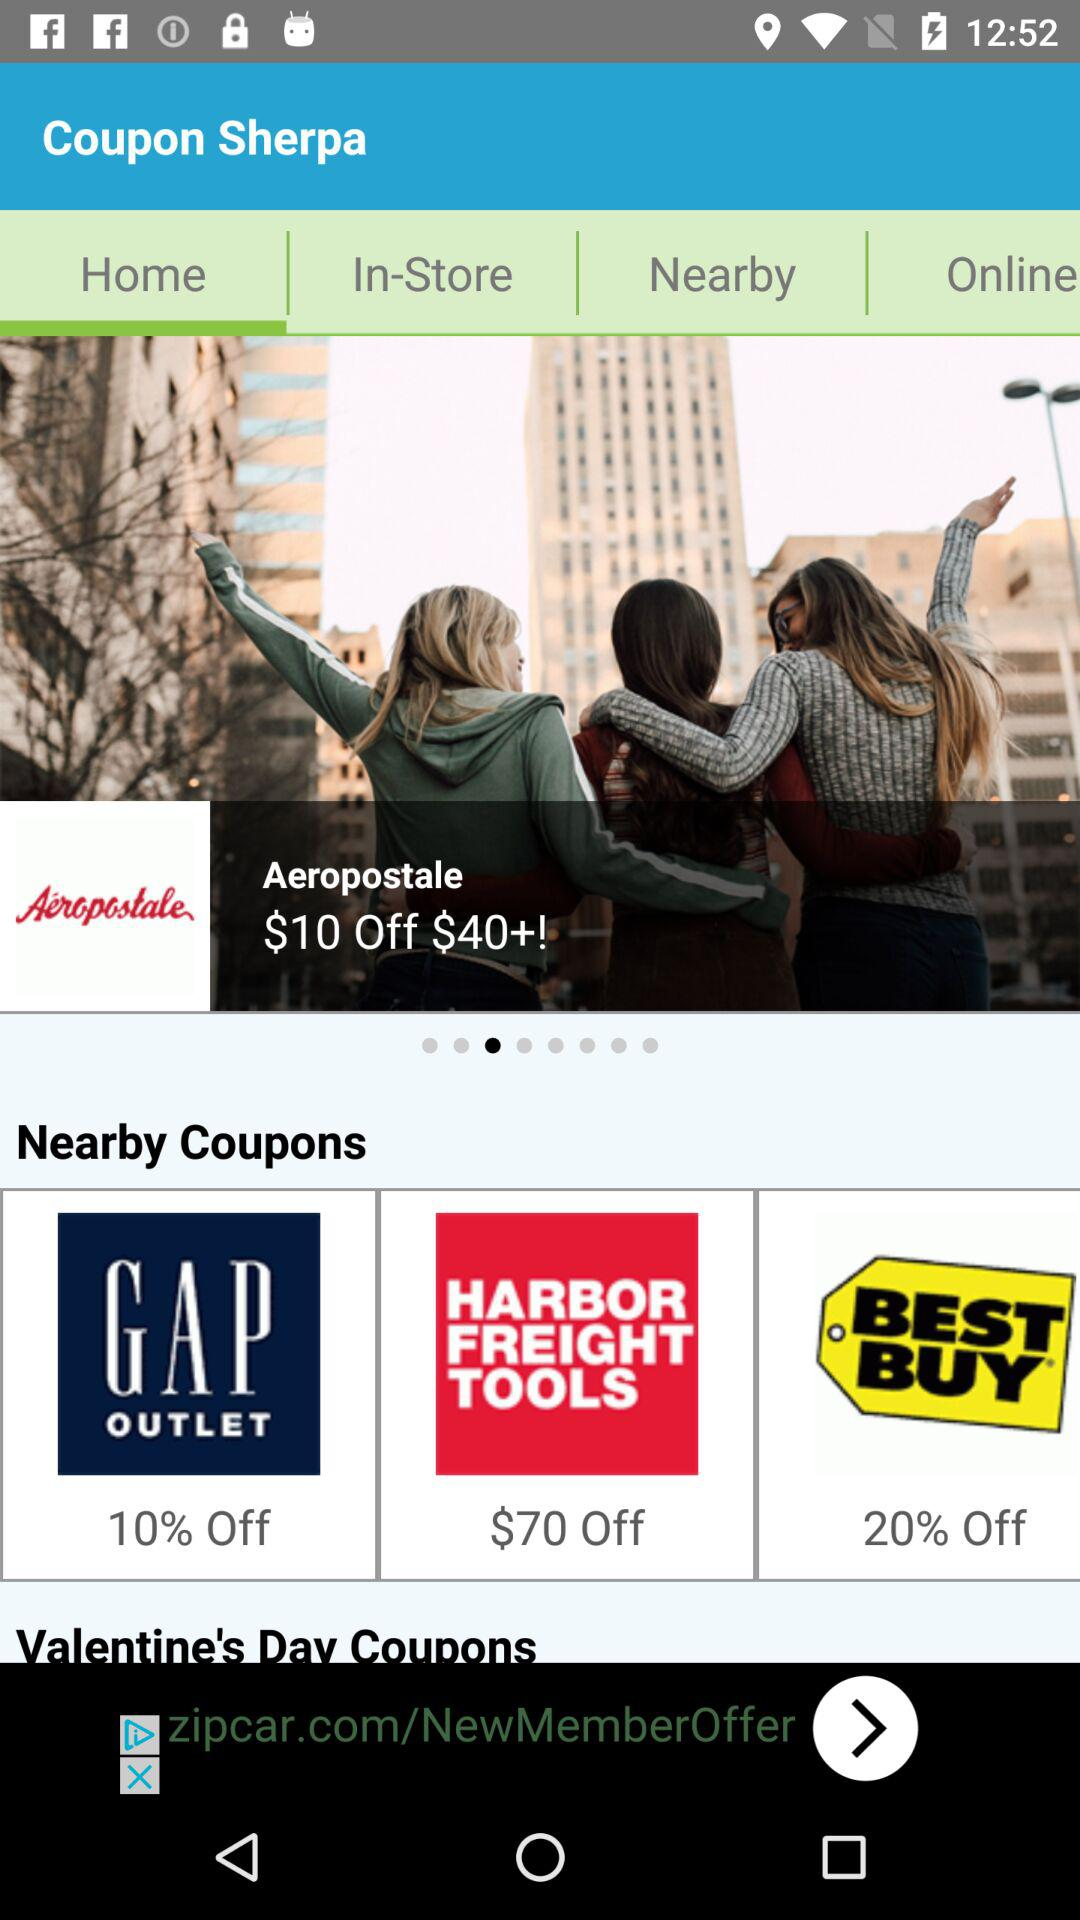How much is off on "BEST BUY"? There is 20% off on "BEST BUY". 